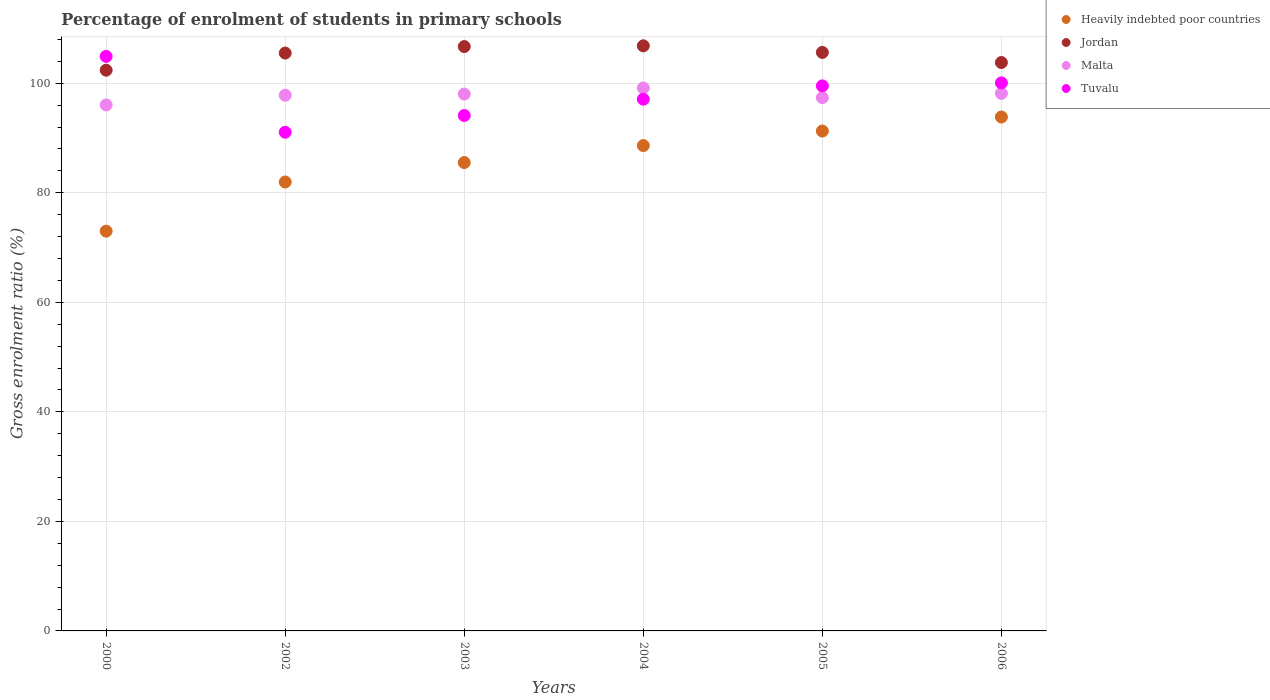How many different coloured dotlines are there?
Offer a terse response. 4. Is the number of dotlines equal to the number of legend labels?
Keep it short and to the point. Yes. What is the percentage of students enrolled in primary schools in Heavily indebted poor countries in 2000?
Ensure brevity in your answer.  72.99. Across all years, what is the maximum percentage of students enrolled in primary schools in Heavily indebted poor countries?
Your response must be concise. 93.84. Across all years, what is the minimum percentage of students enrolled in primary schools in Jordan?
Your response must be concise. 102.39. In which year was the percentage of students enrolled in primary schools in Malta maximum?
Offer a terse response. 2004. What is the total percentage of students enrolled in primary schools in Jordan in the graph?
Your response must be concise. 630.85. What is the difference between the percentage of students enrolled in primary schools in Heavily indebted poor countries in 2002 and that in 2004?
Offer a terse response. -6.65. What is the difference between the percentage of students enrolled in primary schools in Heavily indebted poor countries in 2002 and the percentage of students enrolled in primary schools in Tuvalu in 2005?
Give a very brief answer. -17.54. What is the average percentage of students enrolled in primary schools in Tuvalu per year?
Give a very brief answer. 97.79. In the year 2003, what is the difference between the percentage of students enrolled in primary schools in Malta and percentage of students enrolled in primary schools in Heavily indebted poor countries?
Ensure brevity in your answer.  12.51. What is the ratio of the percentage of students enrolled in primary schools in Tuvalu in 2002 to that in 2005?
Your answer should be compact. 0.91. Is the percentage of students enrolled in primary schools in Jordan in 2003 less than that in 2006?
Your answer should be very brief. No. Is the difference between the percentage of students enrolled in primary schools in Malta in 2003 and 2006 greater than the difference between the percentage of students enrolled in primary schools in Heavily indebted poor countries in 2003 and 2006?
Provide a short and direct response. Yes. What is the difference between the highest and the second highest percentage of students enrolled in primary schools in Jordan?
Provide a short and direct response. 0.13. What is the difference between the highest and the lowest percentage of students enrolled in primary schools in Jordan?
Your answer should be compact. 4.45. In how many years, is the percentage of students enrolled in primary schools in Malta greater than the average percentage of students enrolled in primary schools in Malta taken over all years?
Make the answer very short. 4. Is it the case that in every year, the sum of the percentage of students enrolled in primary schools in Malta and percentage of students enrolled in primary schools in Heavily indebted poor countries  is greater than the sum of percentage of students enrolled in primary schools in Jordan and percentage of students enrolled in primary schools in Tuvalu?
Keep it short and to the point. No. How many dotlines are there?
Offer a terse response. 4. How many years are there in the graph?
Provide a short and direct response. 6. Does the graph contain grids?
Make the answer very short. Yes. Where does the legend appear in the graph?
Your answer should be very brief. Top right. How are the legend labels stacked?
Your answer should be compact. Vertical. What is the title of the graph?
Offer a very short reply. Percentage of enrolment of students in primary schools. What is the label or title of the X-axis?
Your response must be concise. Years. What is the label or title of the Y-axis?
Make the answer very short. Gross enrolment ratio (%). What is the Gross enrolment ratio (%) in Heavily indebted poor countries in 2000?
Offer a very short reply. 72.99. What is the Gross enrolment ratio (%) of Jordan in 2000?
Ensure brevity in your answer.  102.39. What is the Gross enrolment ratio (%) in Malta in 2000?
Provide a short and direct response. 96.04. What is the Gross enrolment ratio (%) in Tuvalu in 2000?
Provide a succinct answer. 104.91. What is the Gross enrolment ratio (%) in Heavily indebted poor countries in 2002?
Ensure brevity in your answer.  81.97. What is the Gross enrolment ratio (%) in Jordan in 2002?
Offer a very short reply. 105.51. What is the Gross enrolment ratio (%) in Malta in 2002?
Your response must be concise. 97.81. What is the Gross enrolment ratio (%) in Tuvalu in 2002?
Keep it short and to the point. 91.06. What is the Gross enrolment ratio (%) in Heavily indebted poor countries in 2003?
Your answer should be compact. 85.52. What is the Gross enrolment ratio (%) in Jordan in 2003?
Give a very brief answer. 106.7. What is the Gross enrolment ratio (%) of Malta in 2003?
Give a very brief answer. 98.03. What is the Gross enrolment ratio (%) in Tuvalu in 2003?
Provide a succinct answer. 94.12. What is the Gross enrolment ratio (%) of Heavily indebted poor countries in 2004?
Give a very brief answer. 88.62. What is the Gross enrolment ratio (%) in Jordan in 2004?
Offer a terse response. 106.83. What is the Gross enrolment ratio (%) of Malta in 2004?
Provide a succinct answer. 99.14. What is the Gross enrolment ratio (%) of Tuvalu in 2004?
Your response must be concise. 97.1. What is the Gross enrolment ratio (%) in Heavily indebted poor countries in 2005?
Your answer should be very brief. 91.28. What is the Gross enrolment ratio (%) of Jordan in 2005?
Offer a very short reply. 105.63. What is the Gross enrolment ratio (%) in Malta in 2005?
Ensure brevity in your answer.  97.38. What is the Gross enrolment ratio (%) in Tuvalu in 2005?
Provide a succinct answer. 99.52. What is the Gross enrolment ratio (%) of Heavily indebted poor countries in 2006?
Make the answer very short. 93.84. What is the Gross enrolment ratio (%) of Jordan in 2006?
Your answer should be compact. 103.79. What is the Gross enrolment ratio (%) of Malta in 2006?
Give a very brief answer. 98.15. What is the Gross enrolment ratio (%) of Tuvalu in 2006?
Your response must be concise. 100.07. Across all years, what is the maximum Gross enrolment ratio (%) in Heavily indebted poor countries?
Ensure brevity in your answer.  93.84. Across all years, what is the maximum Gross enrolment ratio (%) in Jordan?
Provide a short and direct response. 106.83. Across all years, what is the maximum Gross enrolment ratio (%) in Malta?
Provide a succinct answer. 99.14. Across all years, what is the maximum Gross enrolment ratio (%) of Tuvalu?
Keep it short and to the point. 104.91. Across all years, what is the minimum Gross enrolment ratio (%) of Heavily indebted poor countries?
Provide a short and direct response. 72.99. Across all years, what is the minimum Gross enrolment ratio (%) of Jordan?
Make the answer very short. 102.39. Across all years, what is the minimum Gross enrolment ratio (%) in Malta?
Offer a very short reply. 96.04. Across all years, what is the minimum Gross enrolment ratio (%) in Tuvalu?
Your response must be concise. 91.06. What is the total Gross enrolment ratio (%) of Heavily indebted poor countries in the graph?
Your answer should be very brief. 514.23. What is the total Gross enrolment ratio (%) in Jordan in the graph?
Your answer should be very brief. 630.85. What is the total Gross enrolment ratio (%) of Malta in the graph?
Give a very brief answer. 586.55. What is the total Gross enrolment ratio (%) of Tuvalu in the graph?
Offer a terse response. 586.77. What is the difference between the Gross enrolment ratio (%) in Heavily indebted poor countries in 2000 and that in 2002?
Ensure brevity in your answer.  -8.98. What is the difference between the Gross enrolment ratio (%) of Jordan in 2000 and that in 2002?
Offer a terse response. -3.12. What is the difference between the Gross enrolment ratio (%) of Malta in 2000 and that in 2002?
Keep it short and to the point. -1.77. What is the difference between the Gross enrolment ratio (%) in Tuvalu in 2000 and that in 2002?
Provide a succinct answer. 13.85. What is the difference between the Gross enrolment ratio (%) of Heavily indebted poor countries in 2000 and that in 2003?
Offer a terse response. -12.53. What is the difference between the Gross enrolment ratio (%) of Jordan in 2000 and that in 2003?
Make the answer very short. -4.31. What is the difference between the Gross enrolment ratio (%) of Malta in 2000 and that in 2003?
Provide a short and direct response. -1.99. What is the difference between the Gross enrolment ratio (%) of Tuvalu in 2000 and that in 2003?
Your response must be concise. 10.79. What is the difference between the Gross enrolment ratio (%) in Heavily indebted poor countries in 2000 and that in 2004?
Your answer should be compact. -15.63. What is the difference between the Gross enrolment ratio (%) of Jordan in 2000 and that in 2004?
Provide a succinct answer. -4.45. What is the difference between the Gross enrolment ratio (%) of Malta in 2000 and that in 2004?
Ensure brevity in your answer.  -3.09. What is the difference between the Gross enrolment ratio (%) in Tuvalu in 2000 and that in 2004?
Keep it short and to the point. 7.81. What is the difference between the Gross enrolment ratio (%) in Heavily indebted poor countries in 2000 and that in 2005?
Keep it short and to the point. -18.28. What is the difference between the Gross enrolment ratio (%) of Jordan in 2000 and that in 2005?
Your answer should be very brief. -3.25. What is the difference between the Gross enrolment ratio (%) in Malta in 2000 and that in 2005?
Offer a very short reply. -1.34. What is the difference between the Gross enrolment ratio (%) of Tuvalu in 2000 and that in 2005?
Provide a short and direct response. 5.39. What is the difference between the Gross enrolment ratio (%) of Heavily indebted poor countries in 2000 and that in 2006?
Provide a succinct answer. -20.85. What is the difference between the Gross enrolment ratio (%) in Jordan in 2000 and that in 2006?
Provide a succinct answer. -1.4. What is the difference between the Gross enrolment ratio (%) in Malta in 2000 and that in 2006?
Ensure brevity in your answer.  -2.11. What is the difference between the Gross enrolment ratio (%) of Tuvalu in 2000 and that in 2006?
Your answer should be compact. 4.84. What is the difference between the Gross enrolment ratio (%) of Heavily indebted poor countries in 2002 and that in 2003?
Give a very brief answer. -3.55. What is the difference between the Gross enrolment ratio (%) in Jordan in 2002 and that in 2003?
Provide a succinct answer. -1.19. What is the difference between the Gross enrolment ratio (%) of Malta in 2002 and that in 2003?
Your answer should be compact. -0.21. What is the difference between the Gross enrolment ratio (%) of Tuvalu in 2002 and that in 2003?
Make the answer very short. -3.06. What is the difference between the Gross enrolment ratio (%) of Heavily indebted poor countries in 2002 and that in 2004?
Your answer should be compact. -6.65. What is the difference between the Gross enrolment ratio (%) of Jordan in 2002 and that in 2004?
Offer a terse response. -1.32. What is the difference between the Gross enrolment ratio (%) in Malta in 2002 and that in 2004?
Offer a terse response. -1.32. What is the difference between the Gross enrolment ratio (%) of Tuvalu in 2002 and that in 2004?
Your answer should be very brief. -6.04. What is the difference between the Gross enrolment ratio (%) in Heavily indebted poor countries in 2002 and that in 2005?
Give a very brief answer. -9.3. What is the difference between the Gross enrolment ratio (%) in Jordan in 2002 and that in 2005?
Ensure brevity in your answer.  -0.12. What is the difference between the Gross enrolment ratio (%) in Malta in 2002 and that in 2005?
Offer a terse response. 0.44. What is the difference between the Gross enrolment ratio (%) of Tuvalu in 2002 and that in 2005?
Keep it short and to the point. -8.46. What is the difference between the Gross enrolment ratio (%) of Heavily indebted poor countries in 2002 and that in 2006?
Ensure brevity in your answer.  -11.86. What is the difference between the Gross enrolment ratio (%) in Jordan in 2002 and that in 2006?
Your answer should be compact. 1.72. What is the difference between the Gross enrolment ratio (%) in Malta in 2002 and that in 2006?
Your answer should be very brief. -0.34. What is the difference between the Gross enrolment ratio (%) of Tuvalu in 2002 and that in 2006?
Your response must be concise. -9.01. What is the difference between the Gross enrolment ratio (%) in Heavily indebted poor countries in 2003 and that in 2004?
Offer a very short reply. -3.1. What is the difference between the Gross enrolment ratio (%) of Jordan in 2003 and that in 2004?
Offer a very short reply. -0.13. What is the difference between the Gross enrolment ratio (%) in Malta in 2003 and that in 2004?
Offer a terse response. -1.11. What is the difference between the Gross enrolment ratio (%) of Tuvalu in 2003 and that in 2004?
Give a very brief answer. -2.98. What is the difference between the Gross enrolment ratio (%) of Heavily indebted poor countries in 2003 and that in 2005?
Ensure brevity in your answer.  -5.76. What is the difference between the Gross enrolment ratio (%) in Jordan in 2003 and that in 2005?
Offer a terse response. 1.07. What is the difference between the Gross enrolment ratio (%) in Malta in 2003 and that in 2005?
Make the answer very short. 0.65. What is the difference between the Gross enrolment ratio (%) in Tuvalu in 2003 and that in 2005?
Provide a succinct answer. -5.4. What is the difference between the Gross enrolment ratio (%) in Heavily indebted poor countries in 2003 and that in 2006?
Make the answer very short. -8.32. What is the difference between the Gross enrolment ratio (%) of Jordan in 2003 and that in 2006?
Your answer should be compact. 2.91. What is the difference between the Gross enrolment ratio (%) in Malta in 2003 and that in 2006?
Provide a short and direct response. -0.13. What is the difference between the Gross enrolment ratio (%) of Tuvalu in 2003 and that in 2006?
Your answer should be very brief. -5.95. What is the difference between the Gross enrolment ratio (%) in Heavily indebted poor countries in 2004 and that in 2005?
Your answer should be very brief. -2.65. What is the difference between the Gross enrolment ratio (%) of Jordan in 2004 and that in 2005?
Give a very brief answer. 1.2. What is the difference between the Gross enrolment ratio (%) in Malta in 2004 and that in 2005?
Your response must be concise. 1.76. What is the difference between the Gross enrolment ratio (%) of Tuvalu in 2004 and that in 2005?
Make the answer very short. -2.42. What is the difference between the Gross enrolment ratio (%) of Heavily indebted poor countries in 2004 and that in 2006?
Your answer should be compact. -5.22. What is the difference between the Gross enrolment ratio (%) in Jordan in 2004 and that in 2006?
Your answer should be very brief. 3.05. What is the difference between the Gross enrolment ratio (%) in Malta in 2004 and that in 2006?
Your response must be concise. 0.98. What is the difference between the Gross enrolment ratio (%) of Tuvalu in 2004 and that in 2006?
Ensure brevity in your answer.  -2.97. What is the difference between the Gross enrolment ratio (%) in Heavily indebted poor countries in 2005 and that in 2006?
Your answer should be very brief. -2.56. What is the difference between the Gross enrolment ratio (%) in Jordan in 2005 and that in 2006?
Make the answer very short. 1.85. What is the difference between the Gross enrolment ratio (%) of Malta in 2005 and that in 2006?
Your answer should be very brief. -0.78. What is the difference between the Gross enrolment ratio (%) in Tuvalu in 2005 and that in 2006?
Keep it short and to the point. -0.55. What is the difference between the Gross enrolment ratio (%) in Heavily indebted poor countries in 2000 and the Gross enrolment ratio (%) in Jordan in 2002?
Offer a very short reply. -32.52. What is the difference between the Gross enrolment ratio (%) in Heavily indebted poor countries in 2000 and the Gross enrolment ratio (%) in Malta in 2002?
Your answer should be compact. -24.82. What is the difference between the Gross enrolment ratio (%) of Heavily indebted poor countries in 2000 and the Gross enrolment ratio (%) of Tuvalu in 2002?
Ensure brevity in your answer.  -18.06. What is the difference between the Gross enrolment ratio (%) of Jordan in 2000 and the Gross enrolment ratio (%) of Malta in 2002?
Give a very brief answer. 4.57. What is the difference between the Gross enrolment ratio (%) in Jordan in 2000 and the Gross enrolment ratio (%) in Tuvalu in 2002?
Your answer should be compact. 11.33. What is the difference between the Gross enrolment ratio (%) in Malta in 2000 and the Gross enrolment ratio (%) in Tuvalu in 2002?
Your response must be concise. 4.98. What is the difference between the Gross enrolment ratio (%) of Heavily indebted poor countries in 2000 and the Gross enrolment ratio (%) of Jordan in 2003?
Provide a short and direct response. -33.71. What is the difference between the Gross enrolment ratio (%) in Heavily indebted poor countries in 2000 and the Gross enrolment ratio (%) in Malta in 2003?
Your response must be concise. -25.03. What is the difference between the Gross enrolment ratio (%) in Heavily indebted poor countries in 2000 and the Gross enrolment ratio (%) in Tuvalu in 2003?
Give a very brief answer. -21.12. What is the difference between the Gross enrolment ratio (%) in Jordan in 2000 and the Gross enrolment ratio (%) in Malta in 2003?
Give a very brief answer. 4.36. What is the difference between the Gross enrolment ratio (%) of Jordan in 2000 and the Gross enrolment ratio (%) of Tuvalu in 2003?
Your answer should be compact. 8.27. What is the difference between the Gross enrolment ratio (%) of Malta in 2000 and the Gross enrolment ratio (%) of Tuvalu in 2003?
Your response must be concise. 1.92. What is the difference between the Gross enrolment ratio (%) of Heavily indebted poor countries in 2000 and the Gross enrolment ratio (%) of Jordan in 2004?
Make the answer very short. -33.84. What is the difference between the Gross enrolment ratio (%) in Heavily indebted poor countries in 2000 and the Gross enrolment ratio (%) in Malta in 2004?
Keep it short and to the point. -26.14. What is the difference between the Gross enrolment ratio (%) in Heavily indebted poor countries in 2000 and the Gross enrolment ratio (%) in Tuvalu in 2004?
Ensure brevity in your answer.  -24.1. What is the difference between the Gross enrolment ratio (%) of Jordan in 2000 and the Gross enrolment ratio (%) of Malta in 2004?
Provide a short and direct response. 3.25. What is the difference between the Gross enrolment ratio (%) in Jordan in 2000 and the Gross enrolment ratio (%) in Tuvalu in 2004?
Offer a terse response. 5.29. What is the difference between the Gross enrolment ratio (%) in Malta in 2000 and the Gross enrolment ratio (%) in Tuvalu in 2004?
Offer a terse response. -1.05. What is the difference between the Gross enrolment ratio (%) in Heavily indebted poor countries in 2000 and the Gross enrolment ratio (%) in Jordan in 2005?
Provide a short and direct response. -32.64. What is the difference between the Gross enrolment ratio (%) of Heavily indebted poor countries in 2000 and the Gross enrolment ratio (%) of Malta in 2005?
Make the answer very short. -24.38. What is the difference between the Gross enrolment ratio (%) in Heavily indebted poor countries in 2000 and the Gross enrolment ratio (%) in Tuvalu in 2005?
Your answer should be very brief. -26.53. What is the difference between the Gross enrolment ratio (%) of Jordan in 2000 and the Gross enrolment ratio (%) of Malta in 2005?
Offer a terse response. 5.01. What is the difference between the Gross enrolment ratio (%) in Jordan in 2000 and the Gross enrolment ratio (%) in Tuvalu in 2005?
Your answer should be compact. 2.87. What is the difference between the Gross enrolment ratio (%) in Malta in 2000 and the Gross enrolment ratio (%) in Tuvalu in 2005?
Offer a very short reply. -3.48. What is the difference between the Gross enrolment ratio (%) of Heavily indebted poor countries in 2000 and the Gross enrolment ratio (%) of Jordan in 2006?
Ensure brevity in your answer.  -30.79. What is the difference between the Gross enrolment ratio (%) of Heavily indebted poor countries in 2000 and the Gross enrolment ratio (%) of Malta in 2006?
Your response must be concise. -25.16. What is the difference between the Gross enrolment ratio (%) of Heavily indebted poor countries in 2000 and the Gross enrolment ratio (%) of Tuvalu in 2006?
Your answer should be very brief. -27.07. What is the difference between the Gross enrolment ratio (%) of Jordan in 2000 and the Gross enrolment ratio (%) of Malta in 2006?
Your answer should be compact. 4.23. What is the difference between the Gross enrolment ratio (%) in Jordan in 2000 and the Gross enrolment ratio (%) in Tuvalu in 2006?
Your answer should be compact. 2.32. What is the difference between the Gross enrolment ratio (%) of Malta in 2000 and the Gross enrolment ratio (%) of Tuvalu in 2006?
Provide a short and direct response. -4.03. What is the difference between the Gross enrolment ratio (%) in Heavily indebted poor countries in 2002 and the Gross enrolment ratio (%) in Jordan in 2003?
Your answer should be compact. -24.73. What is the difference between the Gross enrolment ratio (%) in Heavily indebted poor countries in 2002 and the Gross enrolment ratio (%) in Malta in 2003?
Offer a terse response. -16.05. What is the difference between the Gross enrolment ratio (%) of Heavily indebted poor countries in 2002 and the Gross enrolment ratio (%) of Tuvalu in 2003?
Keep it short and to the point. -12.14. What is the difference between the Gross enrolment ratio (%) of Jordan in 2002 and the Gross enrolment ratio (%) of Malta in 2003?
Ensure brevity in your answer.  7.48. What is the difference between the Gross enrolment ratio (%) of Jordan in 2002 and the Gross enrolment ratio (%) of Tuvalu in 2003?
Offer a terse response. 11.39. What is the difference between the Gross enrolment ratio (%) in Malta in 2002 and the Gross enrolment ratio (%) in Tuvalu in 2003?
Make the answer very short. 3.7. What is the difference between the Gross enrolment ratio (%) in Heavily indebted poor countries in 2002 and the Gross enrolment ratio (%) in Jordan in 2004?
Offer a terse response. -24.86. What is the difference between the Gross enrolment ratio (%) of Heavily indebted poor countries in 2002 and the Gross enrolment ratio (%) of Malta in 2004?
Keep it short and to the point. -17.16. What is the difference between the Gross enrolment ratio (%) of Heavily indebted poor countries in 2002 and the Gross enrolment ratio (%) of Tuvalu in 2004?
Make the answer very short. -15.12. What is the difference between the Gross enrolment ratio (%) of Jordan in 2002 and the Gross enrolment ratio (%) of Malta in 2004?
Keep it short and to the point. 6.38. What is the difference between the Gross enrolment ratio (%) of Jordan in 2002 and the Gross enrolment ratio (%) of Tuvalu in 2004?
Provide a succinct answer. 8.42. What is the difference between the Gross enrolment ratio (%) in Malta in 2002 and the Gross enrolment ratio (%) in Tuvalu in 2004?
Offer a very short reply. 0.72. What is the difference between the Gross enrolment ratio (%) in Heavily indebted poor countries in 2002 and the Gross enrolment ratio (%) in Jordan in 2005?
Keep it short and to the point. -23.66. What is the difference between the Gross enrolment ratio (%) of Heavily indebted poor countries in 2002 and the Gross enrolment ratio (%) of Malta in 2005?
Your answer should be compact. -15.4. What is the difference between the Gross enrolment ratio (%) of Heavily indebted poor countries in 2002 and the Gross enrolment ratio (%) of Tuvalu in 2005?
Your answer should be compact. -17.54. What is the difference between the Gross enrolment ratio (%) of Jordan in 2002 and the Gross enrolment ratio (%) of Malta in 2005?
Make the answer very short. 8.13. What is the difference between the Gross enrolment ratio (%) in Jordan in 2002 and the Gross enrolment ratio (%) in Tuvalu in 2005?
Ensure brevity in your answer.  5.99. What is the difference between the Gross enrolment ratio (%) in Malta in 2002 and the Gross enrolment ratio (%) in Tuvalu in 2005?
Your answer should be compact. -1.71. What is the difference between the Gross enrolment ratio (%) in Heavily indebted poor countries in 2002 and the Gross enrolment ratio (%) in Jordan in 2006?
Ensure brevity in your answer.  -21.81. What is the difference between the Gross enrolment ratio (%) in Heavily indebted poor countries in 2002 and the Gross enrolment ratio (%) in Malta in 2006?
Provide a succinct answer. -16.18. What is the difference between the Gross enrolment ratio (%) in Heavily indebted poor countries in 2002 and the Gross enrolment ratio (%) in Tuvalu in 2006?
Ensure brevity in your answer.  -18.09. What is the difference between the Gross enrolment ratio (%) of Jordan in 2002 and the Gross enrolment ratio (%) of Malta in 2006?
Keep it short and to the point. 7.36. What is the difference between the Gross enrolment ratio (%) in Jordan in 2002 and the Gross enrolment ratio (%) in Tuvalu in 2006?
Your answer should be compact. 5.44. What is the difference between the Gross enrolment ratio (%) in Malta in 2002 and the Gross enrolment ratio (%) in Tuvalu in 2006?
Keep it short and to the point. -2.25. What is the difference between the Gross enrolment ratio (%) in Heavily indebted poor countries in 2003 and the Gross enrolment ratio (%) in Jordan in 2004?
Offer a very short reply. -21.31. What is the difference between the Gross enrolment ratio (%) in Heavily indebted poor countries in 2003 and the Gross enrolment ratio (%) in Malta in 2004?
Provide a succinct answer. -13.61. What is the difference between the Gross enrolment ratio (%) of Heavily indebted poor countries in 2003 and the Gross enrolment ratio (%) of Tuvalu in 2004?
Your response must be concise. -11.57. What is the difference between the Gross enrolment ratio (%) of Jordan in 2003 and the Gross enrolment ratio (%) of Malta in 2004?
Give a very brief answer. 7.57. What is the difference between the Gross enrolment ratio (%) in Jordan in 2003 and the Gross enrolment ratio (%) in Tuvalu in 2004?
Provide a succinct answer. 9.6. What is the difference between the Gross enrolment ratio (%) of Malta in 2003 and the Gross enrolment ratio (%) of Tuvalu in 2004?
Make the answer very short. 0.93. What is the difference between the Gross enrolment ratio (%) of Heavily indebted poor countries in 2003 and the Gross enrolment ratio (%) of Jordan in 2005?
Provide a short and direct response. -20.11. What is the difference between the Gross enrolment ratio (%) of Heavily indebted poor countries in 2003 and the Gross enrolment ratio (%) of Malta in 2005?
Keep it short and to the point. -11.86. What is the difference between the Gross enrolment ratio (%) in Heavily indebted poor countries in 2003 and the Gross enrolment ratio (%) in Tuvalu in 2005?
Give a very brief answer. -14. What is the difference between the Gross enrolment ratio (%) in Jordan in 2003 and the Gross enrolment ratio (%) in Malta in 2005?
Give a very brief answer. 9.32. What is the difference between the Gross enrolment ratio (%) of Jordan in 2003 and the Gross enrolment ratio (%) of Tuvalu in 2005?
Your response must be concise. 7.18. What is the difference between the Gross enrolment ratio (%) of Malta in 2003 and the Gross enrolment ratio (%) of Tuvalu in 2005?
Provide a short and direct response. -1.49. What is the difference between the Gross enrolment ratio (%) in Heavily indebted poor countries in 2003 and the Gross enrolment ratio (%) in Jordan in 2006?
Provide a succinct answer. -18.26. What is the difference between the Gross enrolment ratio (%) in Heavily indebted poor countries in 2003 and the Gross enrolment ratio (%) in Malta in 2006?
Offer a very short reply. -12.63. What is the difference between the Gross enrolment ratio (%) of Heavily indebted poor countries in 2003 and the Gross enrolment ratio (%) of Tuvalu in 2006?
Your answer should be compact. -14.55. What is the difference between the Gross enrolment ratio (%) of Jordan in 2003 and the Gross enrolment ratio (%) of Malta in 2006?
Provide a short and direct response. 8.55. What is the difference between the Gross enrolment ratio (%) in Jordan in 2003 and the Gross enrolment ratio (%) in Tuvalu in 2006?
Your answer should be compact. 6.63. What is the difference between the Gross enrolment ratio (%) in Malta in 2003 and the Gross enrolment ratio (%) in Tuvalu in 2006?
Offer a terse response. -2.04. What is the difference between the Gross enrolment ratio (%) in Heavily indebted poor countries in 2004 and the Gross enrolment ratio (%) in Jordan in 2005?
Ensure brevity in your answer.  -17.01. What is the difference between the Gross enrolment ratio (%) in Heavily indebted poor countries in 2004 and the Gross enrolment ratio (%) in Malta in 2005?
Provide a succinct answer. -8.75. What is the difference between the Gross enrolment ratio (%) of Heavily indebted poor countries in 2004 and the Gross enrolment ratio (%) of Tuvalu in 2005?
Give a very brief answer. -10.9. What is the difference between the Gross enrolment ratio (%) of Jordan in 2004 and the Gross enrolment ratio (%) of Malta in 2005?
Your answer should be compact. 9.45. What is the difference between the Gross enrolment ratio (%) in Jordan in 2004 and the Gross enrolment ratio (%) in Tuvalu in 2005?
Ensure brevity in your answer.  7.31. What is the difference between the Gross enrolment ratio (%) in Malta in 2004 and the Gross enrolment ratio (%) in Tuvalu in 2005?
Offer a terse response. -0.38. What is the difference between the Gross enrolment ratio (%) of Heavily indebted poor countries in 2004 and the Gross enrolment ratio (%) of Jordan in 2006?
Offer a very short reply. -15.16. What is the difference between the Gross enrolment ratio (%) of Heavily indebted poor countries in 2004 and the Gross enrolment ratio (%) of Malta in 2006?
Your answer should be very brief. -9.53. What is the difference between the Gross enrolment ratio (%) of Heavily indebted poor countries in 2004 and the Gross enrolment ratio (%) of Tuvalu in 2006?
Your answer should be very brief. -11.44. What is the difference between the Gross enrolment ratio (%) of Jordan in 2004 and the Gross enrolment ratio (%) of Malta in 2006?
Offer a very short reply. 8.68. What is the difference between the Gross enrolment ratio (%) in Jordan in 2004 and the Gross enrolment ratio (%) in Tuvalu in 2006?
Provide a succinct answer. 6.76. What is the difference between the Gross enrolment ratio (%) in Malta in 2004 and the Gross enrolment ratio (%) in Tuvalu in 2006?
Provide a succinct answer. -0.93. What is the difference between the Gross enrolment ratio (%) in Heavily indebted poor countries in 2005 and the Gross enrolment ratio (%) in Jordan in 2006?
Provide a short and direct response. -12.51. What is the difference between the Gross enrolment ratio (%) of Heavily indebted poor countries in 2005 and the Gross enrolment ratio (%) of Malta in 2006?
Ensure brevity in your answer.  -6.88. What is the difference between the Gross enrolment ratio (%) of Heavily indebted poor countries in 2005 and the Gross enrolment ratio (%) of Tuvalu in 2006?
Provide a succinct answer. -8.79. What is the difference between the Gross enrolment ratio (%) in Jordan in 2005 and the Gross enrolment ratio (%) in Malta in 2006?
Give a very brief answer. 7.48. What is the difference between the Gross enrolment ratio (%) in Jordan in 2005 and the Gross enrolment ratio (%) in Tuvalu in 2006?
Your response must be concise. 5.57. What is the difference between the Gross enrolment ratio (%) in Malta in 2005 and the Gross enrolment ratio (%) in Tuvalu in 2006?
Give a very brief answer. -2.69. What is the average Gross enrolment ratio (%) of Heavily indebted poor countries per year?
Your answer should be compact. 85.71. What is the average Gross enrolment ratio (%) of Jordan per year?
Your response must be concise. 105.14. What is the average Gross enrolment ratio (%) in Malta per year?
Provide a short and direct response. 97.76. What is the average Gross enrolment ratio (%) of Tuvalu per year?
Provide a short and direct response. 97.79. In the year 2000, what is the difference between the Gross enrolment ratio (%) of Heavily indebted poor countries and Gross enrolment ratio (%) of Jordan?
Make the answer very short. -29.39. In the year 2000, what is the difference between the Gross enrolment ratio (%) of Heavily indebted poor countries and Gross enrolment ratio (%) of Malta?
Provide a succinct answer. -23.05. In the year 2000, what is the difference between the Gross enrolment ratio (%) of Heavily indebted poor countries and Gross enrolment ratio (%) of Tuvalu?
Offer a very short reply. -31.92. In the year 2000, what is the difference between the Gross enrolment ratio (%) in Jordan and Gross enrolment ratio (%) in Malta?
Your response must be concise. 6.35. In the year 2000, what is the difference between the Gross enrolment ratio (%) of Jordan and Gross enrolment ratio (%) of Tuvalu?
Your answer should be very brief. -2.52. In the year 2000, what is the difference between the Gross enrolment ratio (%) of Malta and Gross enrolment ratio (%) of Tuvalu?
Provide a succinct answer. -8.87. In the year 2002, what is the difference between the Gross enrolment ratio (%) of Heavily indebted poor countries and Gross enrolment ratio (%) of Jordan?
Make the answer very short. -23.54. In the year 2002, what is the difference between the Gross enrolment ratio (%) of Heavily indebted poor countries and Gross enrolment ratio (%) of Malta?
Your response must be concise. -15.84. In the year 2002, what is the difference between the Gross enrolment ratio (%) in Heavily indebted poor countries and Gross enrolment ratio (%) in Tuvalu?
Provide a succinct answer. -9.08. In the year 2002, what is the difference between the Gross enrolment ratio (%) in Jordan and Gross enrolment ratio (%) in Malta?
Your response must be concise. 7.7. In the year 2002, what is the difference between the Gross enrolment ratio (%) of Jordan and Gross enrolment ratio (%) of Tuvalu?
Provide a short and direct response. 14.45. In the year 2002, what is the difference between the Gross enrolment ratio (%) of Malta and Gross enrolment ratio (%) of Tuvalu?
Keep it short and to the point. 6.76. In the year 2003, what is the difference between the Gross enrolment ratio (%) of Heavily indebted poor countries and Gross enrolment ratio (%) of Jordan?
Offer a terse response. -21.18. In the year 2003, what is the difference between the Gross enrolment ratio (%) of Heavily indebted poor countries and Gross enrolment ratio (%) of Malta?
Make the answer very short. -12.51. In the year 2003, what is the difference between the Gross enrolment ratio (%) in Heavily indebted poor countries and Gross enrolment ratio (%) in Tuvalu?
Your answer should be compact. -8.6. In the year 2003, what is the difference between the Gross enrolment ratio (%) in Jordan and Gross enrolment ratio (%) in Malta?
Provide a succinct answer. 8.67. In the year 2003, what is the difference between the Gross enrolment ratio (%) of Jordan and Gross enrolment ratio (%) of Tuvalu?
Ensure brevity in your answer.  12.58. In the year 2003, what is the difference between the Gross enrolment ratio (%) of Malta and Gross enrolment ratio (%) of Tuvalu?
Your answer should be very brief. 3.91. In the year 2004, what is the difference between the Gross enrolment ratio (%) in Heavily indebted poor countries and Gross enrolment ratio (%) in Jordan?
Keep it short and to the point. -18.21. In the year 2004, what is the difference between the Gross enrolment ratio (%) in Heavily indebted poor countries and Gross enrolment ratio (%) in Malta?
Give a very brief answer. -10.51. In the year 2004, what is the difference between the Gross enrolment ratio (%) in Heavily indebted poor countries and Gross enrolment ratio (%) in Tuvalu?
Offer a terse response. -8.47. In the year 2004, what is the difference between the Gross enrolment ratio (%) of Jordan and Gross enrolment ratio (%) of Malta?
Keep it short and to the point. 7.7. In the year 2004, what is the difference between the Gross enrolment ratio (%) in Jordan and Gross enrolment ratio (%) in Tuvalu?
Offer a terse response. 9.74. In the year 2004, what is the difference between the Gross enrolment ratio (%) in Malta and Gross enrolment ratio (%) in Tuvalu?
Make the answer very short. 2.04. In the year 2005, what is the difference between the Gross enrolment ratio (%) in Heavily indebted poor countries and Gross enrolment ratio (%) in Jordan?
Give a very brief answer. -14.36. In the year 2005, what is the difference between the Gross enrolment ratio (%) in Heavily indebted poor countries and Gross enrolment ratio (%) in Malta?
Make the answer very short. -6.1. In the year 2005, what is the difference between the Gross enrolment ratio (%) in Heavily indebted poor countries and Gross enrolment ratio (%) in Tuvalu?
Your response must be concise. -8.24. In the year 2005, what is the difference between the Gross enrolment ratio (%) of Jordan and Gross enrolment ratio (%) of Malta?
Your answer should be very brief. 8.26. In the year 2005, what is the difference between the Gross enrolment ratio (%) of Jordan and Gross enrolment ratio (%) of Tuvalu?
Your response must be concise. 6.11. In the year 2005, what is the difference between the Gross enrolment ratio (%) in Malta and Gross enrolment ratio (%) in Tuvalu?
Give a very brief answer. -2.14. In the year 2006, what is the difference between the Gross enrolment ratio (%) in Heavily indebted poor countries and Gross enrolment ratio (%) in Jordan?
Offer a terse response. -9.95. In the year 2006, what is the difference between the Gross enrolment ratio (%) in Heavily indebted poor countries and Gross enrolment ratio (%) in Malta?
Offer a very short reply. -4.31. In the year 2006, what is the difference between the Gross enrolment ratio (%) of Heavily indebted poor countries and Gross enrolment ratio (%) of Tuvalu?
Provide a short and direct response. -6.23. In the year 2006, what is the difference between the Gross enrolment ratio (%) of Jordan and Gross enrolment ratio (%) of Malta?
Ensure brevity in your answer.  5.63. In the year 2006, what is the difference between the Gross enrolment ratio (%) in Jordan and Gross enrolment ratio (%) in Tuvalu?
Your answer should be compact. 3.72. In the year 2006, what is the difference between the Gross enrolment ratio (%) of Malta and Gross enrolment ratio (%) of Tuvalu?
Ensure brevity in your answer.  -1.91. What is the ratio of the Gross enrolment ratio (%) of Heavily indebted poor countries in 2000 to that in 2002?
Your answer should be very brief. 0.89. What is the ratio of the Gross enrolment ratio (%) of Jordan in 2000 to that in 2002?
Provide a short and direct response. 0.97. What is the ratio of the Gross enrolment ratio (%) of Malta in 2000 to that in 2002?
Your answer should be compact. 0.98. What is the ratio of the Gross enrolment ratio (%) of Tuvalu in 2000 to that in 2002?
Give a very brief answer. 1.15. What is the ratio of the Gross enrolment ratio (%) in Heavily indebted poor countries in 2000 to that in 2003?
Ensure brevity in your answer.  0.85. What is the ratio of the Gross enrolment ratio (%) in Jordan in 2000 to that in 2003?
Provide a short and direct response. 0.96. What is the ratio of the Gross enrolment ratio (%) of Malta in 2000 to that in 2003?
Provide a succinct answer. 0.98. What is the ratio of the Gross enrolment ratio (%) of Tuvalu in 2000 to that in 2003?
Provide a succinct answer. 1.11. What is the ratio of the Gross enrolment ratio (%) of Heavily indebted poor countries in 2000 to that in 2004?
Provide a succinct answer. 0.82. What is the ratio of the Gross enrolment ratio (%) of Jordan in 2000 to that in 2004?
Keep it short and to the point. 0.96. What is the ratio of the Gross enrolment ratio (%) in Malta in 2000 to that in 2004?
Ensure brevity in your answer.  0.97. What is the ratio of the Gross enrolment ratio (%) of Tuvalu in 2000 to that in 2004?
Your response must be concise. 1.08. What is the ratio of the Gross enrolment ratio (%) in Heavily indebted poor countries in 2000 to that in 2005?
Keep it short and to the point. 0.8. What is the ratio of the Gross enrolment ratio (%) of Jordan in 2000 to that in 2005?
Ensure brevity in your answer.  0.97. What is the ratio of the Gross enrolment ratio (%) in Malta in 2000 to that in 2005?
Your response must be concise. 0.99. What is the ratio of the Gross enrolment ratio (%) in Tuvalu in 2000 to that in 2005?
Offer a terse response. 1.05. What is the ratio of the Gross enrolment ratio (%) in Heavily indebted poor countries in 2000 to that in 2006?
Ensure brevity in your answer.  0.78. What is the ratio of the Gross enrolment ratio (%) of Jordan in 2000 to that in 2006?
Provide a short and direct response. 0.99. What is the ratio of the Gross enrolment ratio (%) in Malta in 2000 to that in 2006?
Give a very brief answer. 0.98. What is the ratio of the Gross enrolment ratio (%) in Tuvalu in 2000 to that in 2006?
Give a very brief answer. 1.05. What is the ratio of the Gross enrolment ratio (%) in Heavily indebted poor countries in 2002 to that in 2003?
Provide a succinct answer. 0.96. What is the ratio of the Gross enrolment ratio (%) in Jordan in 2002 to that in 2003?
Your answer should be compact. 0.99. What is the ratio of the Gross enrolment ratio (%) in Malta in 2002 to that in 2003?
Provide a short and direct response. 1. What is the ratio of the Gross enrolment ratio (%) of Tuvalu in 2002 to that in 2003?
Provide a succinct answer. 0.97. What is the ratio of the Gross enrolment ratio (%) of Heavily indebted poor countries in 2002 to that in 2004?
Your response must be concise. 0.93. What is the ratio of the Gross enrolment ratio (%) of Jordan in 2002 to that in 2004?
Keep it short and to the point. 0.99. What is the ratio of the Gross enrolment ratio (%) in Malta in 2002 to that in 2004?
Give a very brief answer. 0.99. What is the ratio of the Gross enrolment ratio (%) in Tuvalu in 2002 to that in 2004?
Provide a short and direct response. 0.94. What is the ratio of the Gross enrolment ratio (%) of Heavily indebted poor countries in 2002 to that in 2005?
Make the answer very short. 0.9. What is the ratio of the Gross enrolment ratio (%) in Tuvalu in 2002 to that in 2005?
Make the answer very short. 0.92. What is the ratio of the Gross enrolment ratio (%) of Heavily indebted poor countries in 2002 to that in 2006?
Keep it short and to the point. 0.87. What is the ratio of the Gross enrolment ratio (%) in Jordan in 2002 to that in 2006?
Offer a terse response. 1.02. What is the ratio of the Gross enrolment ratio (%) of Tuvalu in 2002 to that in 2006?
Your answer should be very brief. 0.91. What is the ratio of the Gross enrolment ratio (%) in Heavily indebted poor countries in 2003 to that in 2004?
Make the answer very short. 0.96. What is the ratio of the Gross enrolment ratio (%) in Jordan in 2003 to that in 2004?
Provide a succinct answer. 1. What is the ratio of the Gross enrolment ratio (%) in Tuvalu in 2003 to that in 2004?
Make the answer very short. 0.97. What is the ratio of the Gross enrolment ratio (%) in Heavily indebted poor countries in 2003 to that in 2005?
Provide a short and direct response. 0.94. What is the ratio of the Gross enrolment ratio (%) of Tuvalu in 2003 to that in 2005?
Make the answer very short. 0.95. What is the ratio of the Gross enrolment ratio (%) of Heavily indebted poor countries in 2003 to that in 2006?
Provide a succinct answer. 0.91. What is the ratio of the Gross enrolment ratio (%) of Jordan in 2003 to that in 2006?
Give a very brief answer. 1.03. What is the ratio of the Gross enrolment ratio (%) in Tuvalu in 2003 to that in 2006?
Ensure brevity in your answer.  0.94. What is the ratio of the Gross enrolment ratio (%) of Heavily indebted poor countries in 2004 to that in 2005?
Ensure brevity in your answer.  0.97. What is the ratio of the Gross enrolment ratio (%) of Jordan in 2004 to that in 2005?
Your answer should be compact. 1.01. What is the ratio of the Gross enrolment ratio (%) of Malta in 2004 to that in 2005?
Provide a succinct answer. 1.02. What is the ratio of the Gross enrolment ratio (%) in Tuvalu in 2004 to that in 2005?
Offer a very short reply. 0.98. What is the ratio of the Gross enrolment ratio (%) of Heavily indebted poor countries in 2004 to that in 2006?
Keep it short and to the point. 0.94. What is the ratio of the Gross enrolment ratio (%) in Jordan in 2004 to that in 2006?
Provide a succinct answer. 1.03. What is the ratio of the Gross enrolment ratio (%) in Tuvalu in 2004 to that in 2006?
Give a very brief answer. 0.97. What is the ratio of the Gross enrolment ratio (%) in Heavily indebted poor countries in 2005 to that in 2006?
Make the answer very short. 0.97. What is the ratio of the Gross enrolment ratio (%) of Jordan in 2005 to that in 2006?
Your answer should be compact. 1.02. What is the difference between the highest and the second highest Gross enrolment ratio (%) in Heavily indebted poor countries?
Provide a succinct answer. 2.56. What is the difference between the highest and the second highest Gross enrolment ratio (%) in Jordan?
Make the answer very short. 0.13. What is the difference between the highest and the second highest Gross enrolment ratio (%) of Malta?
Offer a terse response. 0.98. What is the difference between the highest and the second highest Gross enrolment ratio (%) in Tuvalu?
Your answer should be compact. 4.84. What is the difference between the highest and the lowest Gross enrolment ratio (%) of Heavily indebted poor countries?
Offer a terse response. 20.85. What is the difference between the highest and the lowest Gross enrolment ratio (%) in Jordan?
Make the answer very short. 4.45. What is the difference between the highest and the lowest Gross enrolment ratio (%) in Malta?
Keep it short and to the point. 3.09. What is the difference between the highest and the lowest Gross enrolment ratio (%) of Tuvalu?
Provide a succinct answer. 13.85. 